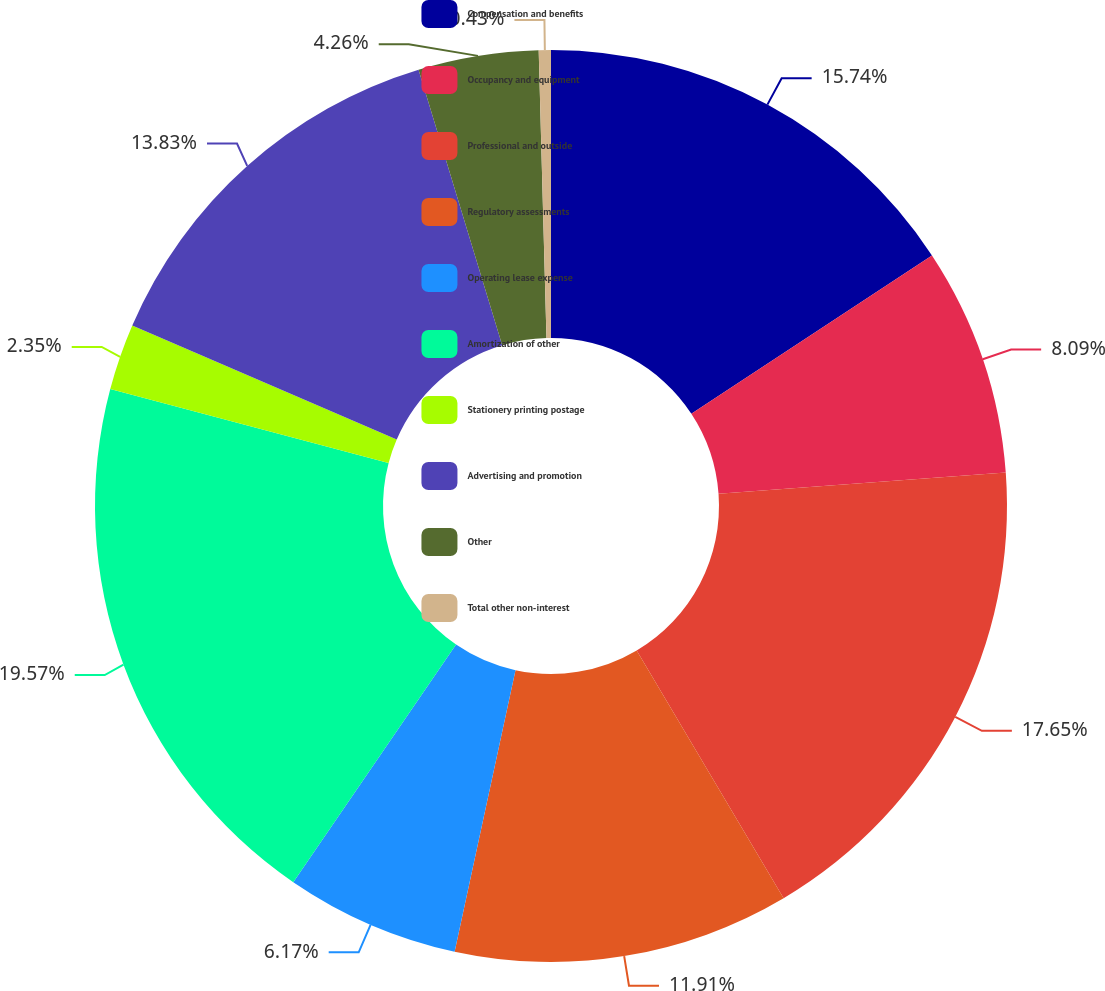<chart> <loc_0><loc_0><loc_500><loc_500><pie_chart><fcel>Compensation and benefits<fcel>Occupancy and equipment<fcel>Professional and outside<fcel>Regulatory assessments<fcel>Operating lease expense<fcel>Amortization of other<fcel>Stationery printing postage<fcel>Advertising and promotion<fcel>Other<fcel>Total other non-interest<nl><fcel>15.74%<fcel>8.09%<fcel>17.65%<fcel>11.91%<fcel>6.17%<fcel>19.57%<fcel>2.35%<fcel>13.83%<fcel>4.26%<fcel>0.43%<nl></chart> 